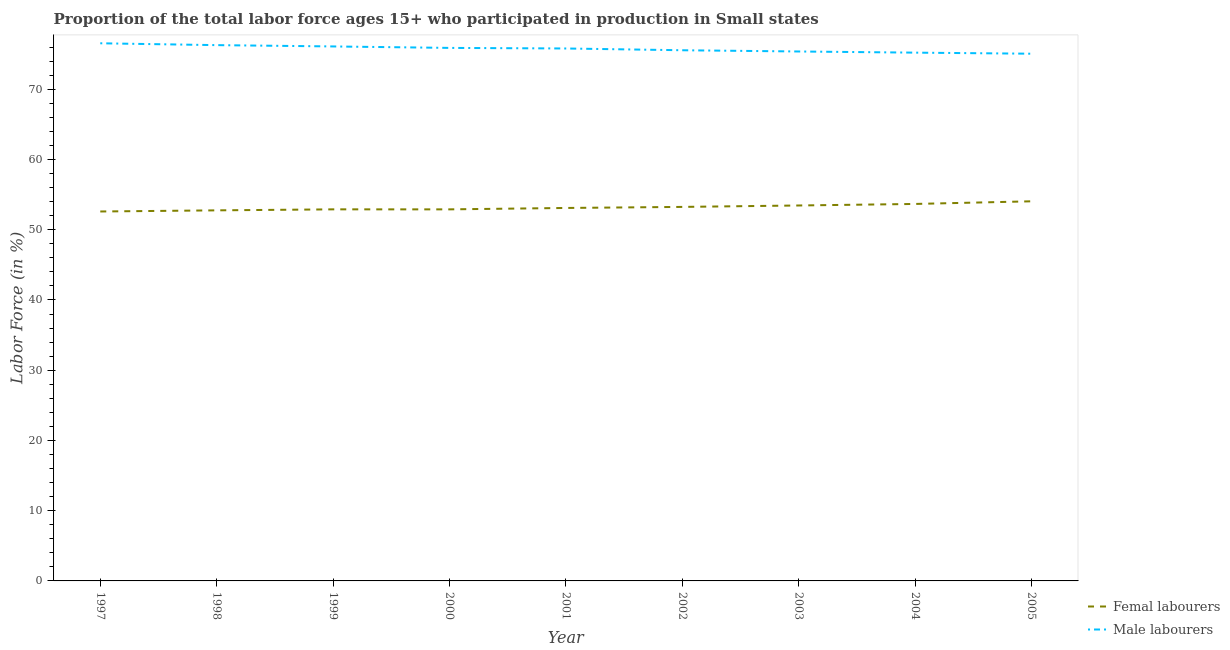How many different coloured lines are there?
Your answer should be very brief. 2. Is the number of lines equal to the number of legend labels?
Your answer should be compact. Yes. What is the percentage of female labor force in 2004?
Ensure brevity in your answer.  53.67. Across all years, what is the maximum percentage of female labor force?
Offer a terse response. 54.04. Across all years, what is the minimum percentage of male labour force?
Offer a very short reply. 75.06. In which year was the percentage of female labor force maximum?
Your response must be concise. 2005. In which year was the percentage of female labor force minimum?
Your answer should be very brief. 1997. What is the total percentage of male labour force in the graph?
Offer a terse response. 681.78. What is the difference between the percentage of female labor force in 2002 and that in 2004?
Offer a terse response. -0.42. What is the difference between the percentage of female labor force in 2005 and the percentage of male labour force in 2002?
Give a very brief answer. -21.5. What is the average percentage of male labour force per year?
Offer a very short reply. 75.75. In the year 2004, what is the difference between the percentage of female labor force and percentage of male labour force?
Give a very brief answer. -21.54. What is the ratio of the percentage of female labor force in 1999 to that in 2003?
Give a very brief answer. 0.99. Is the percentage of female labor force in 1999 less than that in 2000?
Provide a short and direct response. No. Is the difference between the percentage of female labor force in 1998 and 2003 greater than the difference between the percentage of male labour force in 1998 and 2003?
Keep it short and to the point. No. What is the difference between the highest and the second highest percentage of female labor force?
Keep it short and to the point. 0.38. What is the difference between the highest and the lowest percentage of female labor force?
Make the answer very short. 1.45. In how many years, is the percentage of female labor force greater than the average percentage of female labor force taken over all years?
Your response must be concise. 4. Does the percentage of male labour force monotonically increase over the years?
Make the answer very short. No. How many years are there in the graph?
Keep it short and to the point. 9. What is the difference between two consecutive major ticks on the Y-axis?
Your answer should be very brief. 10. How are the legend labels stacked?
Your answer should be compact. Vertical. What is the title of the graph?
Offer a very short reply. Proportion of the total labor force ages 15+ who participated in production in Small states. Does "Primary education" appear as one of the legend labels in the graph?
Provide a short and direct response. No. What is the Labor Force (in %) of Femal labourers in 1997?
Your answer should be compact. 52.59. What is the Labor Force (in %) in Male labourers in 1997?
Your answer should be very brief. 76.54. What is the Labor Force (in %) of Femal labourers in 1998?
Ensure brevity in your answer.  52.76. What is the Labor Force (in %) of Male labourers in 1998?
Keep it short and to the point. 76.28. What is the Labor Force (in %) in Femal labourers in 1999?
Offer a terse response. 52.9. What is the Labor Force (in %) of Male labourers in 1999?
Offer a terse response. 76.09. What is the Labor Force (in %) of Femal labourers in 2000?
Keep it short and to the point. 52.9. What is the Labor Force (in %) of Male labourers in 2000?
Provide a short and direct response. 75.88. What is the Labor Force (in %) of Femal labourers in 2001?
Your response must be concise. 53.1. What is the Labor Force (in %) of Male labourers in 2001?
Provide a short and direct response. 75.8. What is the Labor Force (in %) in Femal labourers in 2002?
Make the answer very short. 53.25. What is the Labor Force (in %) in Male labourers in 2002?
Provide a short and direct response. 75.55. What is the Labor Force (in %) of Femal labourers in 2003?
Offer a very short reply. 53.45. What is the Labor Force (in %) in Male labourers in 2003?
Offer a very short reply. 75.37. What is the Labor Force (in %) of Femal labourers in 2004?
Keep it short and to the point. 53.67. What is the Labor Force (in %) in Male labourers in 2004?
Provide a short and direct response. 75.21. What is the Labor Force (in %) in Femal labourers in 2005?
Make the answer very short. 54.04. What is the Labor Force (in %) in Male labourers in 2005?
Your response must be concise. 75.06. Across all years, what is the maximum Labor Force (in %) of Femal labourers?
Make the answer very short. 54.04. Across all years, what is the maximum Labor Force (in %) of Male labourers?
Provide a short and direct response. 76.54. Across all years, what is the minimum Labor Force (in %) of Femal labourers?
Your response must be concise. 52.59. Across all years, what is the minimum Labor Force (in %) in Male labourers?
Give a very brief answer. 75.06. What is the total Labor Force (in %) of Femal labourers in the graph?
Provide a succinct answer. 478.65. What is the total Labor Force (in %) in Male labourers in the graph?
Provide a succinct answer. 681.78. What is the difference between the Labor Force (in %) in Femal labourers in 1997 and that in 1998?
Give a very brief answer. -0.16. What is the difference between the Labor Force (in %) of Male labourers in 1997 and that in 1998?
Provide a short and direct response. 0.26. What is the difference between the Labor Force (in %) in Femal labourers in 1997 and that in 1999?
Provide a succinct answer. -0.3. What is the difference between the Labor Force (in %) of Male labourers in 1997 and that in 1999?
Ensure brevity in your answer.  0.45. What is the difference between the Labor Force (in %) of Femal labourers in 1997 and that in 2000?
Your response must be concise. -0.3. What is the difference between the Labor Force (in %) in Male labourers in 1997 and that in 2000?
Your answer should be compact. 0.66. What is the difference between the Labor Force (in %) in Femal labourers in 1997 and that in 2001?
Offer a very short reply. -0.5. What is the difference between the Labor Force (in %) in Male labourers in 1997 and that in 2001?
Provide a succinct answer. 0.74. What is the difference between the Labor Force (in %) of Femal labourers in 1997 and that in 2002?
Offer a very short reply. -0.65. What is the difference between the Labor Force (in %) in Male labourers in 1997 and that in 2002?
Your answer should be very brief. 0.99. What is the difference between the Labor Force (in %) of Femal labourers in 1997 and that in 2003?
Your answer should be very brief. -0.86. What is the difference between the Labor Force (in %) in Male labourers in 1997 and that in 2003?
Provide a short and direct response. 1.17. What is the difference between the Labor Force (in %) of Femal labourers in 1997 and that in 2004?
Give a very brief answer. -1.07. What is the difference between the Labor Force (in %) of Male labourers in 1997 and that in 2004?
Keep it short and to the point. 1.33. What is the difference between the Labor Force (in %) of Femal labourers in 1997 and that in 2005?
Provide a short and direct response. -1.45. What is the difference between the Labor Force (in %) of Male labourers in 1997 and that in 2005?
Make the answer very short. 1.48. What is the difference between the Labor Force (in %) of Femal labourers in 1998 and that in 1999?
Your answer should be compact. -0.14. What is the difference between the Labor Force (in %) in Male labourers in 1998 and that in 1999?
Provide a short and direct response. 0.19. What is the difference between the Labor Force (in %) of Femal labourers in 1998 and that in 2000?
Ensure brevity in your answer.  -0.14. What is the difference between the Labor Force (in %) of Male labourers in 1998 and that in 2000?
Provide a short and direct response. 0.39. What is the difference between the Labor Force (in %) of Femal labourers in 1998 and that in 2001?
Give a very brief answer. -0.34. What is the difference between the Labor Force (in %) in Male labourers in 1998 and that in 2001?
Offer a very short reply. 0.48. What is the difference between the Labor Force (in %) of Femal labourers in 1998 and that in 2002?
Your response must be concise. -0.49. What is the difference between the Labor Force (in %) in Male labourers in 1998 and that in 2002?
Your answer should be compact. 0.73. What is the difference between the Labor Force (in %) of Femal labourers in 1998 and that in 2003?
Offer a terse response. -0.69. What is the difference between the Labor Force (in %) of Male labourers in 1998 and that in 2003?
Offer a very short reply. 0.9. What is the difference between the Labor Force (in %) in Femal labourers in 1998 and that in 2004?
Your answer should be compact. -0.91. What is the difference between the Labor Force (in %) in Male labourers in 1998 and that in 2004?
Provide a short and direct response. 1.07. What is the difference between the Labor Force (in %) in Femal labourers in 1998 and that in 2005?
Your response must be concise. -1.29. What is the difference between the Labor Force (in %) of Male labourers in 1998 and that in 2005?
Give a very brief answer. 1.22. What is the difference between the Labor Force (in %) of Femal labourers in 1999 and that in 2000?
Offer a very short reply. 0. What is the difference between the Labor Force (in %) in Male labourers in 1999 and that in 2000?
Your answer should be very brief. 0.21. What is the difference between the Labor Force (in %) in Femal labourers in 1999 and that in 2001?
Provide a succinct answer. -0.2. What is the difference between the Labor Force (in %) of Male labourers in 1999 and that in 2001?
Keep it short and to the point. 0.29. What is the difference between the Labor Force (in %) in Femal labourers in 1999 and that in 2002?
Your answer should be very brief. -0.35. What is the difference between the Labor Force (in %) of Male labourers in 1999 and that in 2002?
Offer a very short reply. 0.54. What is the difference between the Labor Force (in %) of Femal labourers in 1999 and that in 2003?
Make the answer very short. -0.55. What is the difference between the Labor Force (in %) of Male labourers in 1999 and that in 2003?
Provide a succinct answer. 0.72. What is the difference between the Labor Force (in %) of Femal labourers in 1999 and that in 2004?
Ensure brevity in your answer.  -0.77. What is the difference between the Labor Force (in %) in Male labourers in 1999 and that in 2004?
Your response must be concise. 0.88. What is the difference between the Labor Force (in %) of Femal labourers in 1999 and that in 2005?
Your answer should be compact. -1.15. What is the difference between the Labor Force (in %) of Male labourers in 1999 and that in 2005?
Make the answer very short. 1.04. What is the difference between the Labor Force (in %) of Femal labourers in 2000 and that in 2001?
Give a very brief answer. -0.2. What is the difference between the Labor Force (in %) in Male labourers in 2000 and that in 2001?
Ensure brevity in your answer.  0.08. What is the difference between the Labor Force (in %) of Femal labourers in 2000 and that in 2002?
Provide a succinct answer. -0.35. What is the difference between the Labor Force (in %) of Male labourers in 2000 and that in 2002?
Ensure brevity in your answer.  0.33. What is the difference between the Labor Force (in %) in Femal labourers in 2000 and that in 2003?
Offer a terse response. -0.55. What is the difference between the Labor Force (in %) in Male labourers in 2000 and that in 2003?
Provide a succinct answer. 0.51. What is the difference between the Labor Force (in %) in Femal labourers in 2000 and that in 2004?
Your answer should be very brief. -0.77. What is the difference between the Labor Force (in %) of Male labourers in 2000 and that in 2004?
Ensure brevity in your answer.  0.67. What is the difference between the Labor Force (in %) in Femal labourers in 2000 and that in 2005?
Provide a short and direct response. -1.15. What is the difference between the Labor Force (in %) in Male labourers in 2000 and that in 2005?
Your answer should be very brief. 0.83. What is the difference between the Labor Force (in %) of Femal labourers in 2001 and that in 2002?
Offer a very short reply. -0.15. What is the difference between the Labor Force (in %) of Male labourers in 2001 and that in 2002?
Keep it short and to the point. 0.25. What is the difference between the Labor Force (in %) of Femal labourers in 2001 and that in 2003?
Provide a short and direct response. -0.35. What is the difference between the Labor Force (in %) in Male labourers in 2001 and that in 2003?
Make the answer very short. 0.43. What is the difference between the Labor Force (in %) in Femal labourers in 2001 and that in 2004?
Your answer should be very brief. -0.57. What is the difference between the Labor Force (in %) in Male labourers in 2001 and that in 2004?
Offer a very short reply. 0.59. What is the difference between the Labor Force (in %) in Femal labourers in 2001 and that in 2005?
Make the answer very short. -0.95. What is the difference between the Labor Force (in %) of Male labourers in 2001 and that in 2005?
Offer a terse response. 0.75. What is the difference between the Labor Force (in %) in Femal labourers in 2002 and that in 2003?
Your response must be concise. -0.2. What is the difference between the Labor Force (in %) in Male labourers in 2002 and that in 2003?
Offer a terse response. 0.18. What is the difference between the Labor Force (in %) of Femal labourers in 2002 and that in 2004?
Keep it short and to the point. -0.42. What is the difference between the Labor Force (in %) in Male labourers in 2002 and that in 2004?
Your response must be concise. 0.34. What is the difference between the Labor Force (in %) of Femal labourers in 2002 and that in 2005?
Your answer should be very brief. -0.8. What is the difference between the Labor Force (in %) in Male labourers in 2002 and that in 2005?
Ensure brevity in your answer.  0.49. What is the difference between the Labor Force (in %) of Femal labourers in 2003 and that in 2004?
Ensure brevity in your answer.  -0.22. What is the difference between the Labor Force (in %) in Male labourers in 2003 and that in 2004?
Your response must be concise. 0.17. What is the difference between the Labor Force (in %) of Femal labourers in 2003 and that in 2005?
Offer a terse response. -0.59. What is the difference between the Labor Force (in %) in Male labourers in 2003 and that in 2005?
Provide a short and direct response. 0.32. What is the difference between the Labor Force (in %) in Femal labourers in 2004 and that in 2005?
Provide a short and direct response. -0.38. What is the difference between the Labor Force (in %) in Male labourers in 2004 and that in 2005?
Keep it short and to the point. 0.15. What is the difference between the Labor Force (in %) in Femal labourers in 1997 and the Labor Force (in %) in Male labourers in 1998?
Keep it short and to the point. -23.68. What is the difference between the Labor Force (in %) of Femal labourers in 1997 and the Labor Force (in %) of Male labourers in 1999?
Offer a very short reply. -23.5. What is the difference between the Labor Force (in %) of Femal labourers in 1997 and the Labor Force (in %) of Male labourers in 2000?
Provide a succinct answer. -23.29. What is the difference between the Labor Force (in %) of Femal labourers in 1997 and the Labor Force (in %) of Male labourers in 2001?
Offer a very short reply. -23.21. What is the difference between the Labor Force (in %) in Femal labourers in 1997 and the Labor Force (in %) in Male labourers in 2002?
Offer a terse response. -22.95. What is the difference between the Labor Force (in %) of Femal labourers in 1997 and the Labor Force (in %) of Male labourers in 2003?
Your answer should be compact. -22.78. What is the difference between the Labor Force (in %) in Femal labourers in 1997 and the Labor Force (in %) in Male labourers in 2004?
Give a very brief answer. -22.61. What is the difference between the Labor Force (in %) of Femal labourers in 1997 and the Labor Force (in %) of Male labourers in 2005?
Provide a succinct answer. -22.46. What is the difference between the Labor Force (in %) of Femal labourers in 1998 and the Labor Force (in %) of Male labourers in 1999?
Provide a short and direct response. -23.33. What is the difference between the Labor Force (in %) in Femal labourers in 1998 and the Labor Force (in %) in Male labourers in 2000?
Keep it short and to the point. -23.13. What is the difference between the Labor Force (in %) of Femal labourers in 1998 and the Labor Force (in %) of Male labourers in 2001?
Your response must be concise. -23.04. What is the difference between the Labor Force (in %) in Femal labourers in 1998 and the Labor Force (in %) in Male labourers in 2002?
Offer a very short reply. -22.79. What is the difference between the Labor Force (in %) in Femal labourers in 1998 and the Labor Force (in %) in Male labourers in 2003?
Your answer should be compact. -22.62. What is the difference between the Labor Force (in %) in Femal labourers in 1998 and the Labor Force (in %) in Male labourers in 2004?
Offer a terse response. -22.45. What is the difference between the Labor Force (in %) in Femal labourers in 1998 and the Labor Force (in %) in Male labourers in 2005?
Offer a terse response. -22.3. What is the difference between the Labor Force (in %) of Femal labourers in 1999 and the Labor Force (in %) of Male labourers in 2000?
Make the answer very short. -22.98. What is the difference between the Labor Force (in %) in Femal labourers in 1999 and the Labor Force (in %) in Male labourers in 2001?
Provide a succinct answer. -22.9. What is the difference between the Labor Force (in %) of Femal labourers in 1999 and the Labor Force (in %) of Male labourers in 2002?
Your answer should be very brief. -22.65. What is the difference between the Labor Force (in %) of Femal labourers in 1999 and the Labor Force (in %) of Male labourers in 2003?
Provide a short and direct response. -22.47. What is the difference between the Labor Force (in %) of Femal labourers in 1999 and the Labor Force (in %) of Male labourers in 2004?
Your answer should be compact. -22.31. What is the difference between the Labor Force (in %) in Femal labourers in 1999 and the Labor Force (in %) in Male labourers in 2005?
Give a very brief answer. -22.16. What is the difference between the Labor Force (in %) in Femal labourers in 2000 and the Labor Force (in %) in Male labourers in 2001?
Your answer should be compact. -22.9. What is the difference between the Labor Force (in %) of Femal labourers in 2000 and the Labor Force (in %) of Male labourers in 2002?
Your response must be concise. -22.65. What is the difference between the Labor Force (in %) in Femal labourers in 2000 and the Labor Force (in %) in Male labourers in 2003?
Your answer should be very brief. -22.48. What is the difference between the Labor Force (in %) of Femal labourers in 2000 and the Labor Force (in %) of Male labourers in 2004?
Offer a very short reply. -22.31. What is the difference between the Labor Force (in %) in Femal labourers in 2000 and the Labor Force (in %) in Male labourers in 2005?
Give a very brief answer. -22.16. What is the difference between the Labor Force (in %) in Femal labourers in 2001 and the Labor Force (in %) in Male labourers in 2002?
Your answer should be very brief. -22.45. What is the difference between the Labor Force (in %) of Femal labourers in 2001 and the Labor Force (in %) of Male labourers in 2003?
Your answer should be compact. -22.28. What is the difference between the Labor Force (in %) in Femal labourers in 2001 and the Labor Force (in %) in Male labourers in 2004?
Offer a terse response. -22.11. What is the difference between the Labor Force (in %) of Femal labourers in 2001 and the Labor Force (in %) of Male labourers in 2005?
Provide a succinct answer. -21.96. What is the difference between the Labor Force (in %) of Femal labourers in 2002 and the Labor Force (in %) of Male labourers in 2003?
Ensure brevity in your answer.  -22.13. What is the difference between the Labor Force (in %) of Femal labourers in 2002 and the Labor Force (in %) of Male labourers in 2004?
Give a very brief answer. -21.96. What is the difference between the Labor Force (in %) in Femal labourers in 2002 and the Labor Force (in %) in Male labourers in 2005?
Provide a short and direct response. -21.81. What is the difference between the Labor Force (in %) of Femal labourers in 2003 and the Labor Force (in %) of Male labourers in 2004?
Keep it short and to the point. -21.76. What is the difference between the Labor Force (in %) of Femal labourers in 2003 and the Labor Force (in %) of Male labourers in 2005?
Your answer should be very brief. -21.61. What is the difference between the Labor Force (in %) in Femal labourers in 2004 and the Labor Force (in %) in Male labourers in 2005?
Make the answer very short. -21.39. What is the average Labor Force (in %) in Femal labourers per year?
Provide a succinct answer. 53.18. What is the average Labor Force (in %) in Male labourers per year?
Your response must be concise. 75.75. In the year 1997, what is the difference between the Labor Force (in %) in Femal labourers and Labor Force (in %) in Male labourers?
Provide a short and direct response. -23.95. In the year 1998, what is the difference between the Labor Force (in %) in Femal labourers and Labor Force (in %) in Male labourers?
Keep it short and to the point. -23.52. In the year 1999, what is the difference between the Labor Force (in %) of Femal labourers and Labor Force (in %) of Male labourers?
Keep it short and to the point. -23.19. In the year 2000, what is the difference between the Labor Force (in %) in Femal labourers and Labor Force (in %) in Male labourers?
Offer a terse response. -22.99. In the year 2001, what is the difference between the Labor Force (in %) of Femal labourers and Labor Force (in %) of Male labourers?
Your answer should be compact. -22.7. In the year 2002, what is the difference between the Labor Force (in %) in Femal labourers and Labor Force (in %) in Male labourers?
Provide a succinct answer. -22.3. In the year 2003, what is the difference between the Labor Force (in %) of Femal labourers and Labor Force (in %) of Male labourers?
Make the answer very short. -21.92. In the year 2004, what is the difference between the Labor Force (in %) of Femal labourers and Labor Force (in %) of Male labourers?
Your response must be concise. -21.54. In the year 2005, what is the difference between the Labor Force (in %) of Femal labourers and Labor Force (in %) of Male labourers?
Offer a terse response. -21.01. What is the ratio of the Labor Force (in %) of Femal labourers in 1997 to that in 1998?
Keep it short and to the point. 1. What is the ratio of the Labor Force (in %) of Male labourers in 1997 to that in 1999?
Your response must be concise. 1.01. What is the ratio of the Labor Force (in %) of Male labourers in 1997 to that in 2000?
Your response must be concise. 1.01. What is the ratio of the Labor Force (in %) of Femal labourers in 1997 to that in 2001?
Give a very brief answer. 0.99. What is the ratio of the Labor Force (in %) of Male labourers in 1997 to that in 2001?
Give a very brief answer. 1.01. What is the ratio of the Labor Force (in %) in Male labourers in 1997 to that in 2002?
Keep it short and to the point. 1.01. What is the ratio of the Labor Force (in %) in Male labourers in 1997 to that in 2003?
Your response must be concise. 1.02. What is the ratio of the Labor Force (in %) in Femal labourers in 1997 to that in 2004?
Offer a terse response. 0.98. What is the ratio of the Labor Force (in %) of Male labourers in 1997 to that in 2004?
Provide a short and direct response. 1.02. What is the ratio of the Labor Force (in %) in Femal labourers in 1997 to that in 2005?
Your answer should be very brief. 0.97. What is the ratio of the Labor Force (in %) of Male labourers in 1997 to that in 2005?
Make the answer very short. 1.02. What is the ratio of the Labor Force (in %) in Femal labourers in 1998 to that in 2000?
Your response must be concise. 1. What is the ratio of the Labor Force (in %) in Male labourers in 1998 to that in 2000?
Make the answer very short. 1.01. What is the ratio of the Labor Force (in %) of Femal labourers in 1998 to that in 2001?
Provide a short and direct response. 0.99. What is the ratio of the Labor Force (in %) of Male labourers in 1998 to that in 2001?
Your answer should be very brief. 1.01. What is the ratio of the Labor Force (in %) of Femal labourers in 1998 to that in 2002?
Your response must be concise. 0.99. What is the ratio of the Labor Force (in %) of Male labourers in 1998 to that in 2002?
Keep it short and to the point. 1.01. What is the ratio of the Labor Force (in %) in Femal labourers in 1998 to that in 2004?
Offer a very short reply. 0.98. What is the ratio of the Labor Force (in %) of Male labourers in 1998 to that in 2004?
Make the answer very short. 1.01. What is the ratio of the Labor Force (in %) in Femal labourers in 1998 to that in 2005?
Give a very brief answer. 0.98. What is the ratio of the Labor Force (in %) of Male labourers in 1998 to that in 2005?
Provide a short and direct response. 1.02. What is the ratio of the Labor Force (in %) of Male labourers in 1999 to that in 2000?
Keep it short and to the point. 1. What is the ratio of the Labor Force (in %) of Femal labourers in 1999 to that in 2002?
Offer a very short reply. 0.99. What is the ratio of the Labor Force (in %) of Male labourers in 1999 to that in 2003?
Ensure brevity in your answer.  1.01. What is the ratio of the Labor Force (in %) of Femal labourers in 1999 to that in 2004?
Provide a short and direct response. 0.99. What is the ratio of the Labor Force (in %) in Male labourers in 1999 to that in 2004?
Provide a succinct answer. 1.01. What is the ratio of the Labor Force (in %) in Femal labourers in 1999 to that in 2005?
Offer a very short reply. 0.98. What is the ratio of the Labor Force (in %) of Male labourers in 1999 to that in 2005?
Your answer should be very brief. 1.01. What is the ratio of the Labor Force (in %) in Femal labourers in 2000 to that in 2003?
Provide a succinct answer. 0.99. What is the ratio of the Labor Force (in %) in Male labourers in 2000 to that in 2003?
Make the answer very short. 1.01. What is the ratio of the Labor Force (in %) of Femal labourers in 2000 to that in 2004?
Your answer should be very brief. 0.99. What is the ratio of the Labor Force (in %) in Femal labourers in 2000 to that in 2005?
Make the answer very short. 0.98. What is the ratio of the Labor Force (in %) of Male labourers in 2000 to that in 2005?
Your answer should be very brief. 1.01. What is the ratio of the Labor Force (in %) in Femal labourers in 2001 to that in 2004?
Ensure brevity in your answer.  0.99. What is the ratio of the Labor Force (in %) in Male labourers in 2001 to that in 2004?
Keep it short and to the point. 1.01. What is the ratio of the Labor Force (in %) in Femal labourers in 2001 to that in 2005?
Make the answer very short. 0.98. What is the ratio of the Labor Force (in %) of Male labourers in 2001 to that in 2005?
Your response must be concise. 1.01. What is the ratio of the Labor Force (in %) in Male labourers in 2002 to that in 2003?
Ensure brevity in your answer.  1. What is the ratio of the Labor Force (in %) of Male labourers in 2002 to that in 2004?
Offer a very short reply. 1. What is the ratio of the Labor Force (in %) in Femal labourers in 2002 to that in 2005?
Ensure brevity in your answer.  0.99. What is the ratio of the Labor Force (in %) of Male labourers in 2002 to that in 2005?
Offer a terse response. 1.01. What is the ratio of the Labor Force (in %) in Femal labourers in 2003 to that in 2004?
Provide a succinct answer. 1. What is the ratio of the Labor Force (in %) in Femal labourers in 2004 to that in 2005?
Your answer should be compact. 0.99. What is the ratio of the Labor Force (in %) of Male labourers in 2004 to that in 2005?
Provide a succinct answer. 1. What is the difference between the highest and the second highest Labor Force (in %) of Femal labourers?
Your answer should be very brief. 0.38. What is the difference between the highest and the second highest Labor Force (in %) of Male labourers?
Give a very brief answer. 0.26. What is the difference between the highest and the lowest Labor Force (in %) of Femal labourers?
Your answer should be compact. 1.45. What is the difference between the highest and the lowest Labor Force (in %) in Male labourers?
Your answer should be very brief. 1.48. 